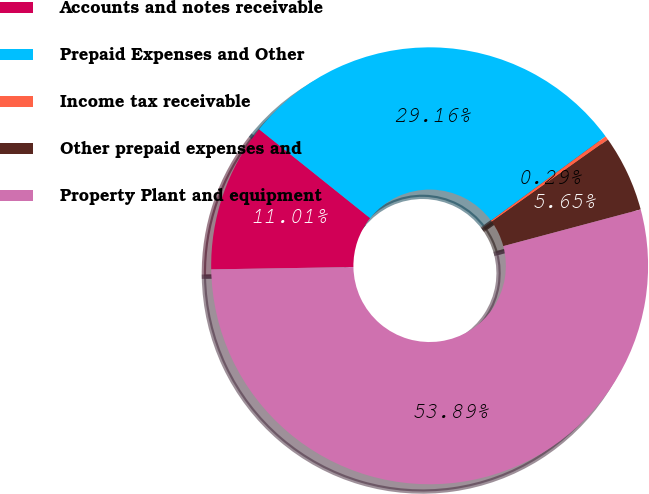Convert chart. <chart><loc_0><loc_0><loc_500><loc_500><pie_chart><fcel>Accounts and notes receivable<fcel>Prepaid Expenses and Other<fcel>Income tax receivable<fcel>Other prepaid expenses and<fcel>Property Plant and equipment<nl><fcel>11.01%<fcel>29.16%<fcel>0.29%<fcel>5.65%<fcel>53.89%<nl></chart> 